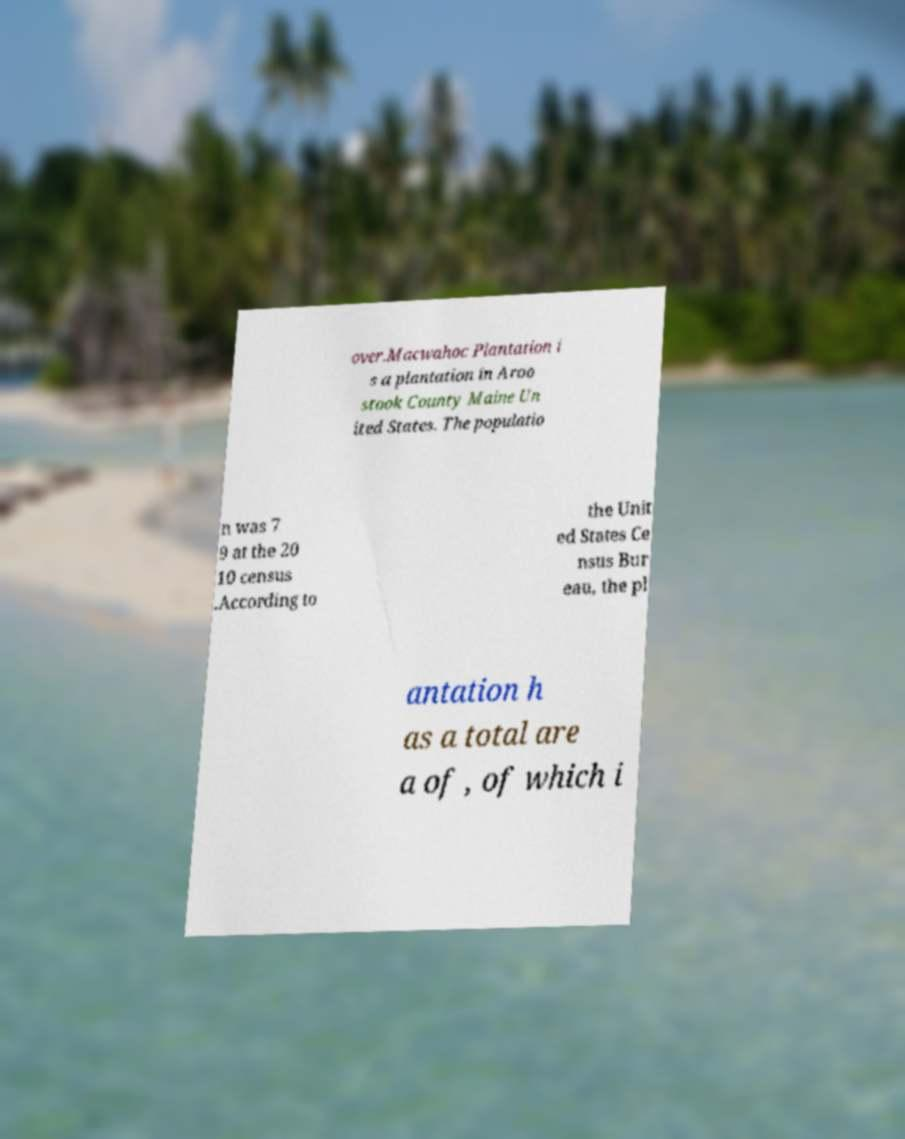Can you read and provide the text displayed in the image?This photo seems to have some interesting text. Can you extract and type it out for me? over.Macwahoc Plantation i s a plantation in Aroo stook County Maine Un ited States. The populatio n was 7 9 at the 20 10 census .According to the Unit ed States Ce nsus Bur eau, the pl antation h as a total are a of , of which i 